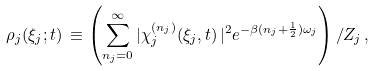Convert formula to latex. <formula><loc_0><loc_0><loc_500><loc_500>\rho _ { j } ( \xi _ { j } ; t ) \, \equiv \left ( \sum _ { n _ { j } = 0 } ^ { \infty } | \chi _ { j } ^ { \left ( n _ { j } \right ) } ( \xi _ { j } , t ) \, | ^ { 2 } e ^ { - \beta ( n _ { j } + \frac { 1 } { 2 } ) \omega _ { j } } \right ) / Z _ { j } \, ,</formula> 